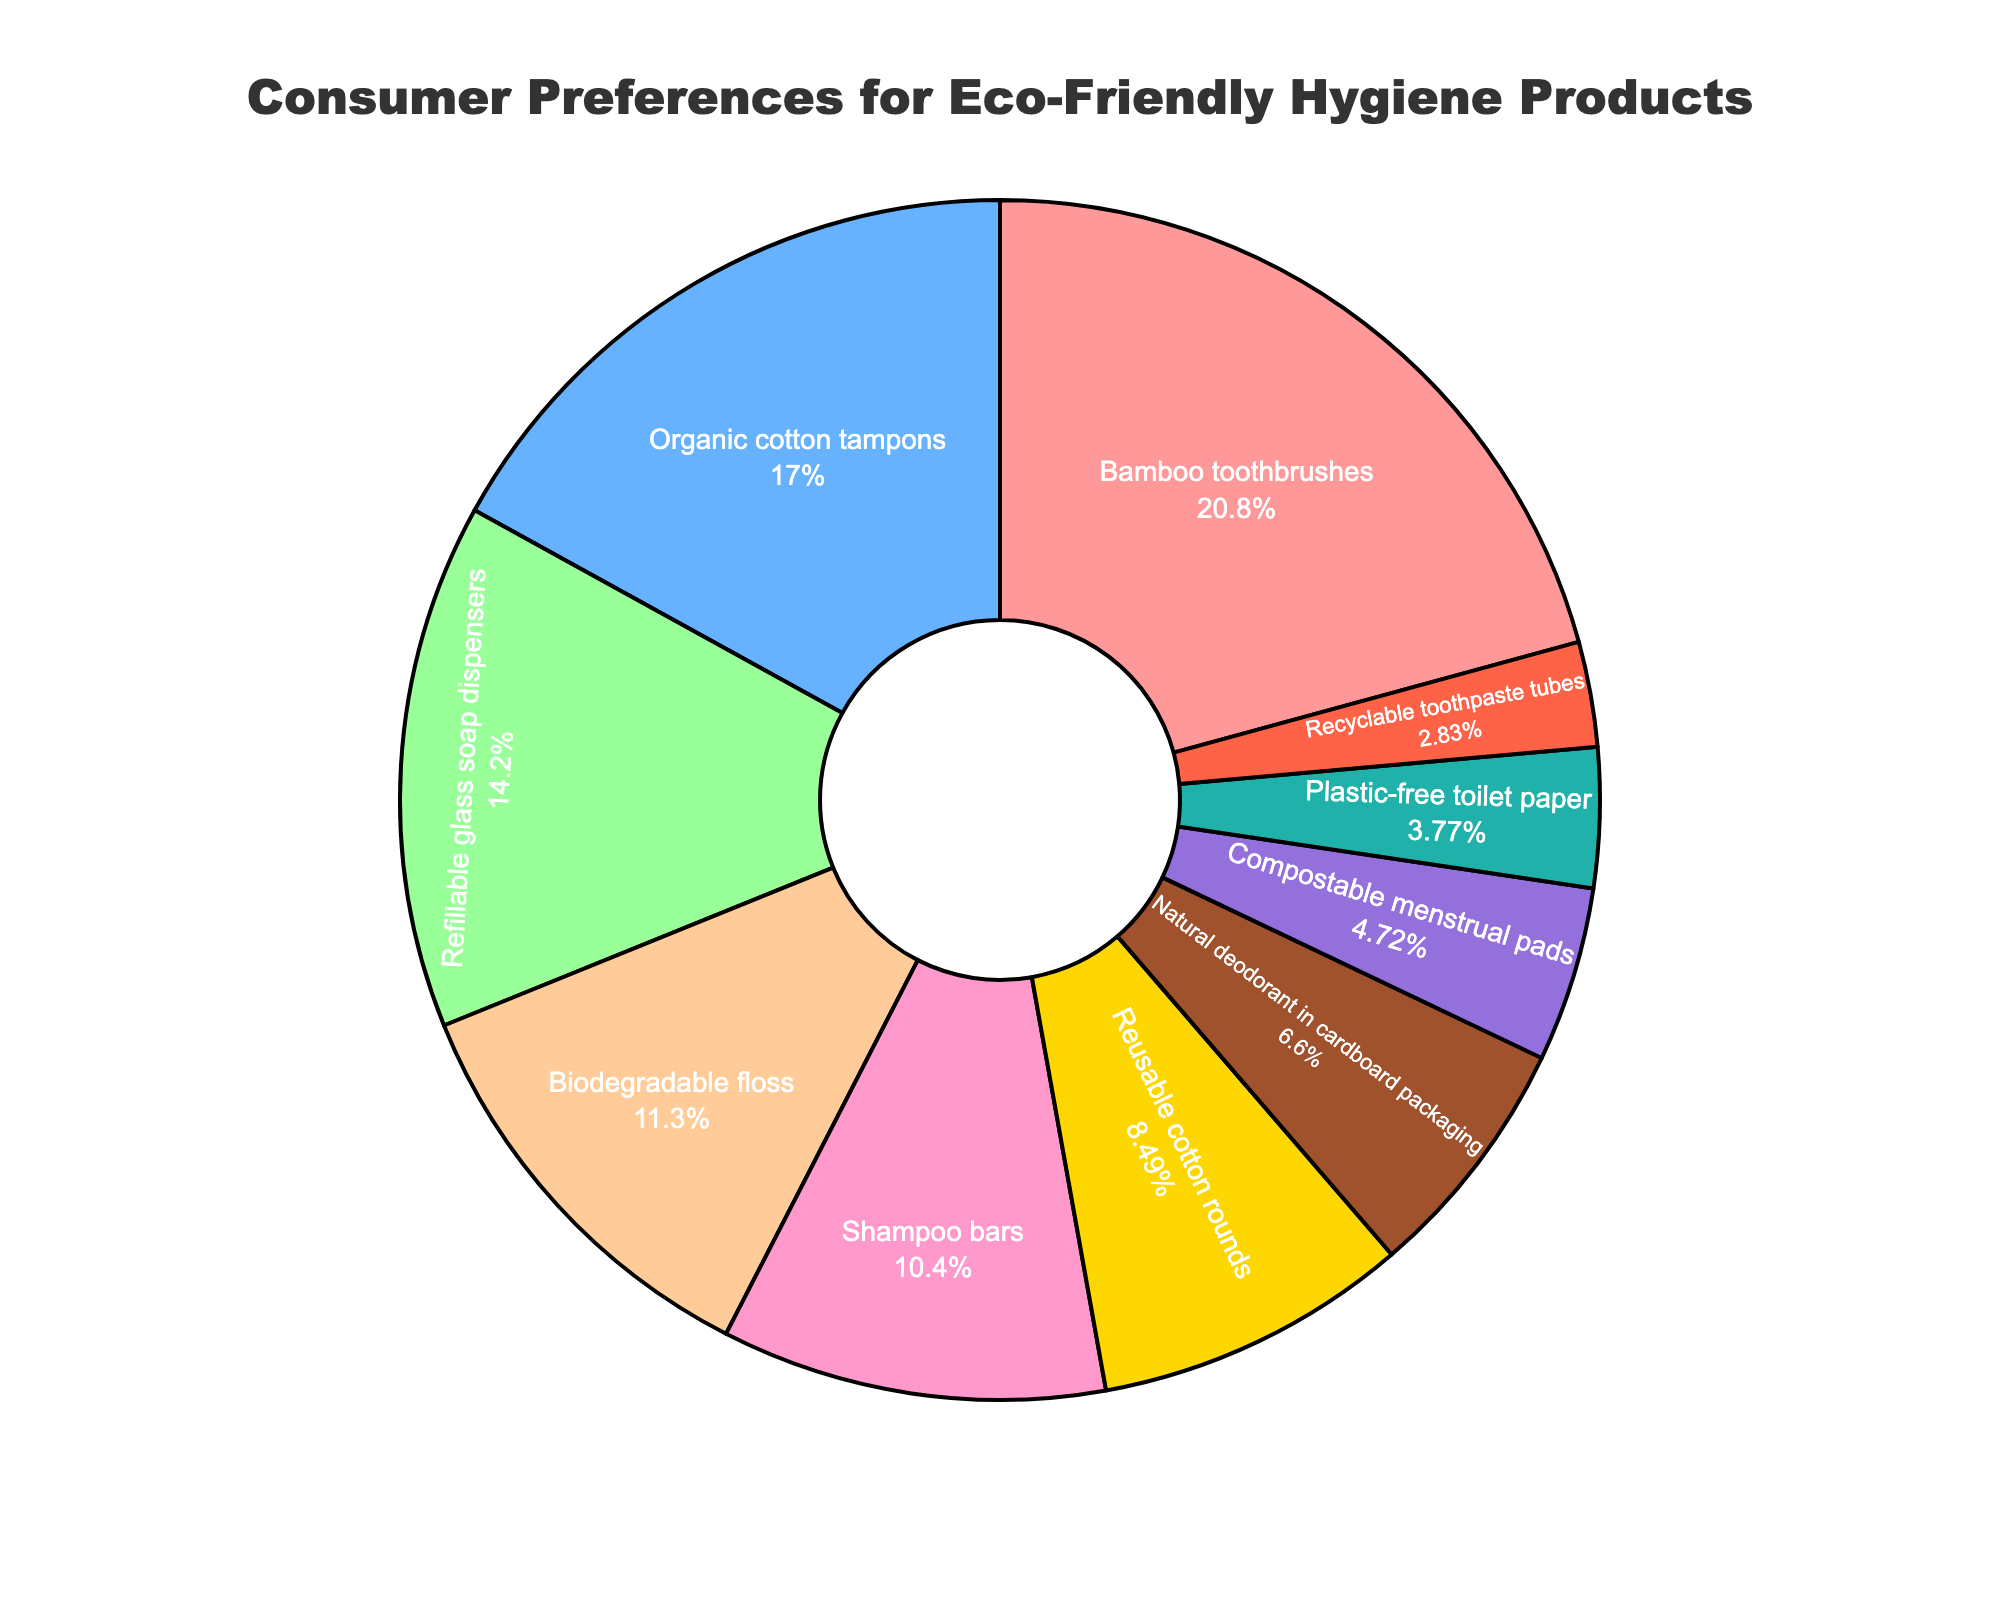Which product has the highest consumer preference? By visually inspecting the pie chart, the product with the largest segment represents the highest consumer preference. This is the "Bamboo toothbrushes" segment.
Answer: Bamboo toothbrushes How many products have a consumer preference percentage of less than 10%? Look for segments of the pie chart where the percentages are explicitly stated and are less than 10%. There are: "Reusable cotton rounds", "Natural deodorant in cardboard packaging", "Compostable menstrual pads", "Plastic-free toilet paper", and "Recyclable toothpaste tubes".
Answer: 5 Which product has a higher preference, biodegradable floss or shampoo bars? Compare the segments that represent biodegradable floss and shampoo bars. The segment for biodegradable floss is larger than that for shampoo bars.
Answer: Biodegradable floss What is the total consumer preference percentage for products with over 15%? Identify and sum the percentages for products that have segments over 15%. These are: "Bamboo toothbrushes" (22%) and "Organic cotton tampons" (18%). So, 22 + 18 = 40.
Answer: 40% Compare the combined preference for shampoo bars and natural deodorant in cardboard packaging to the preference for organic cotton tampons. Which is greater? Add the preferences for "Shampoo bars" (11%) and "Natural deodorant in cardboard packaging" (7%). Compare the result to "Organic cotton tampons" (18%). 11 + 7 = 18, which is equal to 18.
Answer: Equal What is the consumer preference percentage difference between reusable cotton rounds and compostable menstrual pads? Subtract the percentage for "Compostable menstrual pads" (5%) from "Reusable cotton rounds" (9%). 9 - 5 = 4.
Answer: 4% Which product has the smallest consumer preference percentage? Identify the smallest segment in the pie chart. This corresponds to "Recyclable toothpaste tubes" with 3%.
Answer: Recyclable toothpaste tubes Which products together make up exactly half of the total consumer preferences? Identify segments that sum to 50%. "Bamboo toothbrushes" (22%) and "Organic cotton tampons" (18%) sum to 40%, and adding "Refillable glass soap dispensers" (15%) makes it 55%, which is over 50%. Now check "Bamboo toothbrushes" (22%), "Organic cotton tampons" (18%), and "Biodegradable floss" (12%) equaling 52%, which is over 50%. The products "Bamboo toothbrushes" (22%), "Organic cotton tampons" (18%), and "Shampoo bars" (11%) equal 51% which is just over 50%. Therefore, there is no exact combination that sums to exactly 50%.
Answer: None What is the average consumer preference percentage for the top three products? Determine the top three product preferences: "Bamboo toothbrushes" (22%), "Organic cotton tampons" (18%), and "Refillable glass soap dispensers" (15%). Then, calculate the average: (22 + 18 + 15) / 3 = 55 / 3 ≈ 18.33.
Answer: Approximately 18.33% What is the combined percentage of the least three preferred products? Identify the least preferred products: "Recyclable toothpaste tubes" (3%), "Plastic-free toilet paper" (4%), and "Compostable menstrual pads" (5%). Add their percentages: 3 + 4 + 5 = 12.
Answer: 12% 